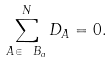<formula> <loc_0><loc_0><loc_500><loc_500>\sum _ { A \in \ B _ { a } } ^ { N } D _ { A } = 0 .</formula> 